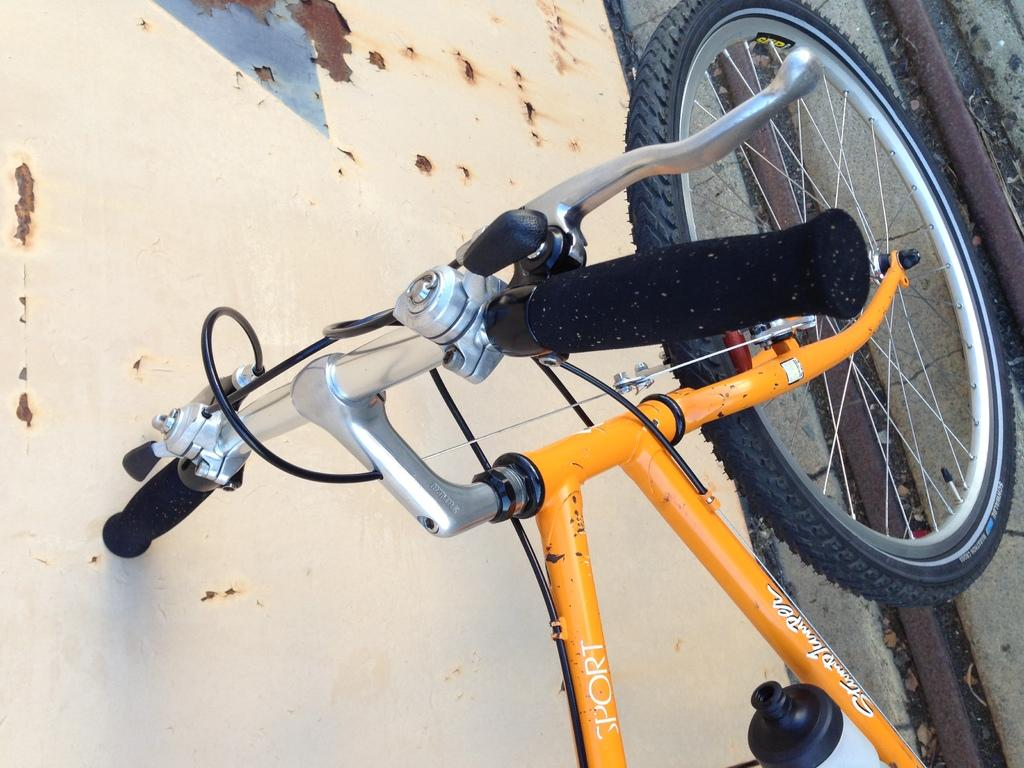What is the main subject of the image? The main subject of the image is a bicycle. Where is the bicycle located in the image? The bicycle is parked on a path. What else can be seen in the background of the image? There is a wall visible in the image. What type of dress is the ocean wearing in the image? There is no ocean or dress present in the image; it features a zoomed in picture of a bicycle parked on a path with a wall in the background. 